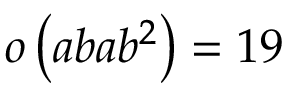<formula> <loc_0><loc_0><loc_500><loc_500>o \left ( a b a b ^ { 2 } \right ) = 1 9</formula> 